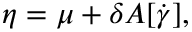Convert formula to latex. <formula><loc_0><loc_0><loc_500><loc_500>\eta = \mu + \delta A { [ \dot { \gamma } ] } ,</formula> 